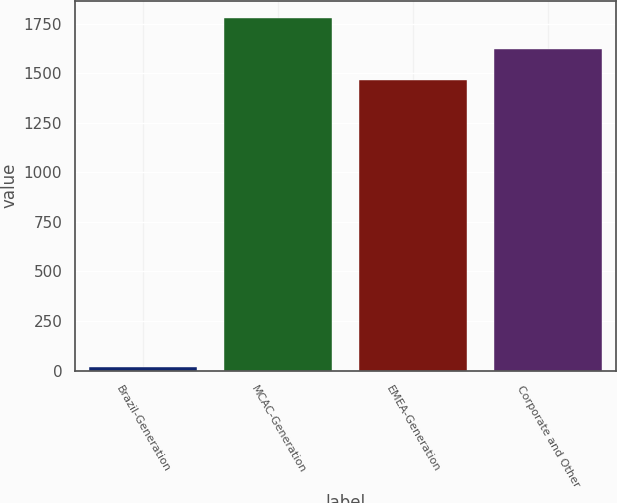<chart> <loc_0><loc_0><loc_500><loc_500><bar_chart><fcel>Brazil-Generation<fcel>MCAC-Generation<fcel>EMEA-Generation<fcel>Corporate and Other<nl><fcel>19<fcel>1777.2<fcel>1467<fcel>1622.1<nl></chart> 